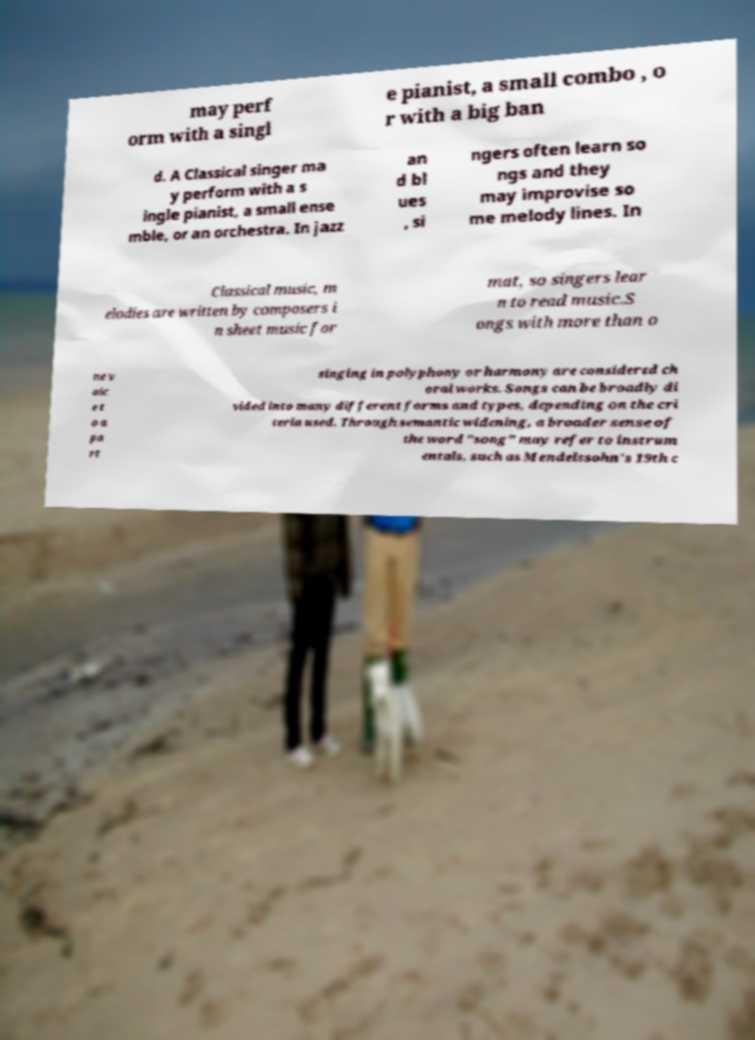Please identify and transcribe the text found in this image. may perf orm with a singl e pianist, a small combo , o r with a big ban d. A Classical singer ma y perform with a s ingle pianist, a small ense mble, or an orchestra. In jazz an d bl ues , si ngers often learn so ngs and they may improvise so me melody lines. In Classical music, m elodies are written by composers i n sheet music for mat, so singers lear n to read music.S ongs with more than o ne v oic e t o a pa rt singing in polyphony or harmony are considered ch oral works. Songs can be broadly di vided into many different forms and types, depending on the cri teria used. Through semantic widening, a broader sense of the word "song" may refer to instrum entals, such as Mendelssohn's 19th c 